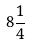Convert formula to latex. <formula><loc_0><loc_0><loc_500><loc_500>8 { \frac { 1 } { 4 } }</formula> 